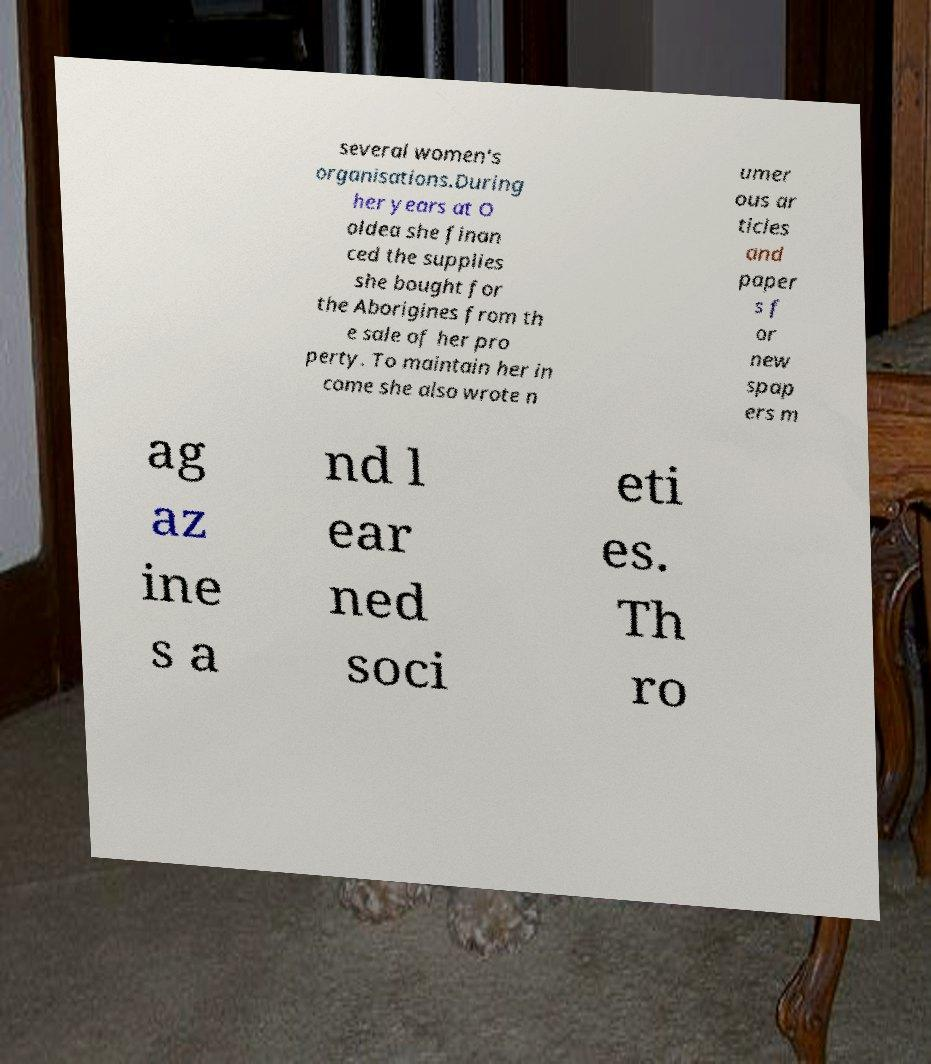For documentation purposes, I need the text within this image transcribed. Could you provide that? several women's organisations.During her years at O oldea she finan ced the supplies she bought for the Aborigines from th e sale of her pro perty. To maintain her in come she also wrote n umer ous ar ticles and paper s f or new spap ers m ag az ine s a nd l ear ned soci eti es. Th ro 